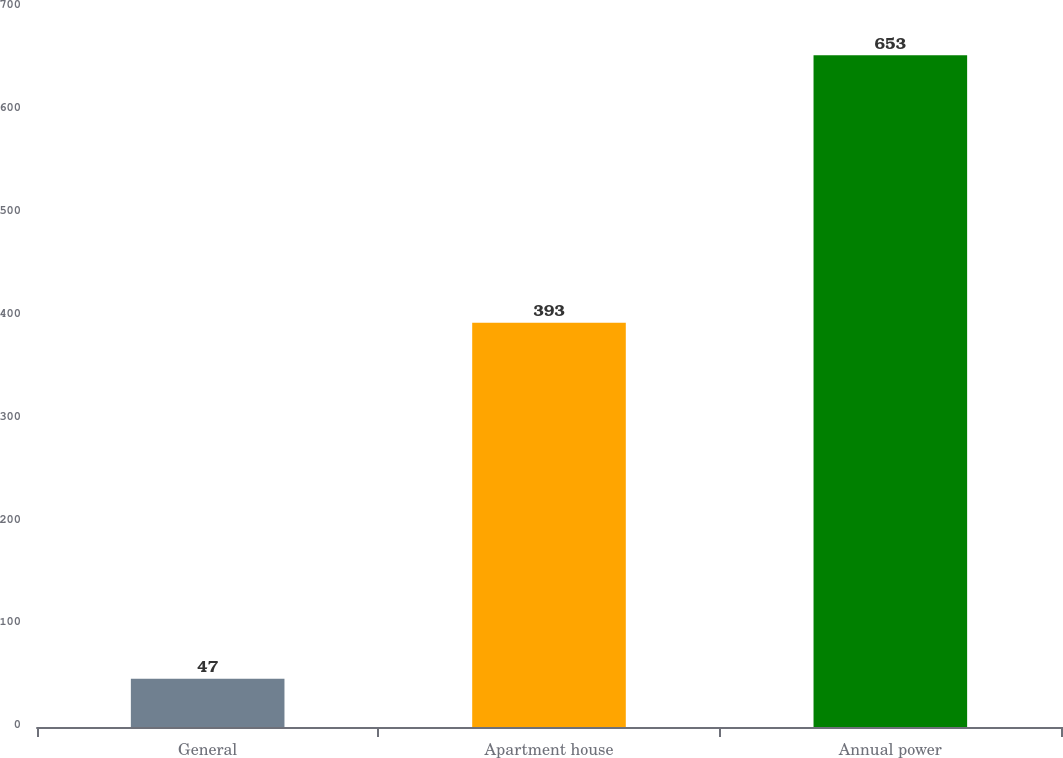<chart> <loc_0><loc_0><loc_500><loc_500><bar_chart><fcel>General<fcel>Apartment house<fcel>Annual power<nl><fcel>47<fcel>393<fcel>653<nl></chart> 